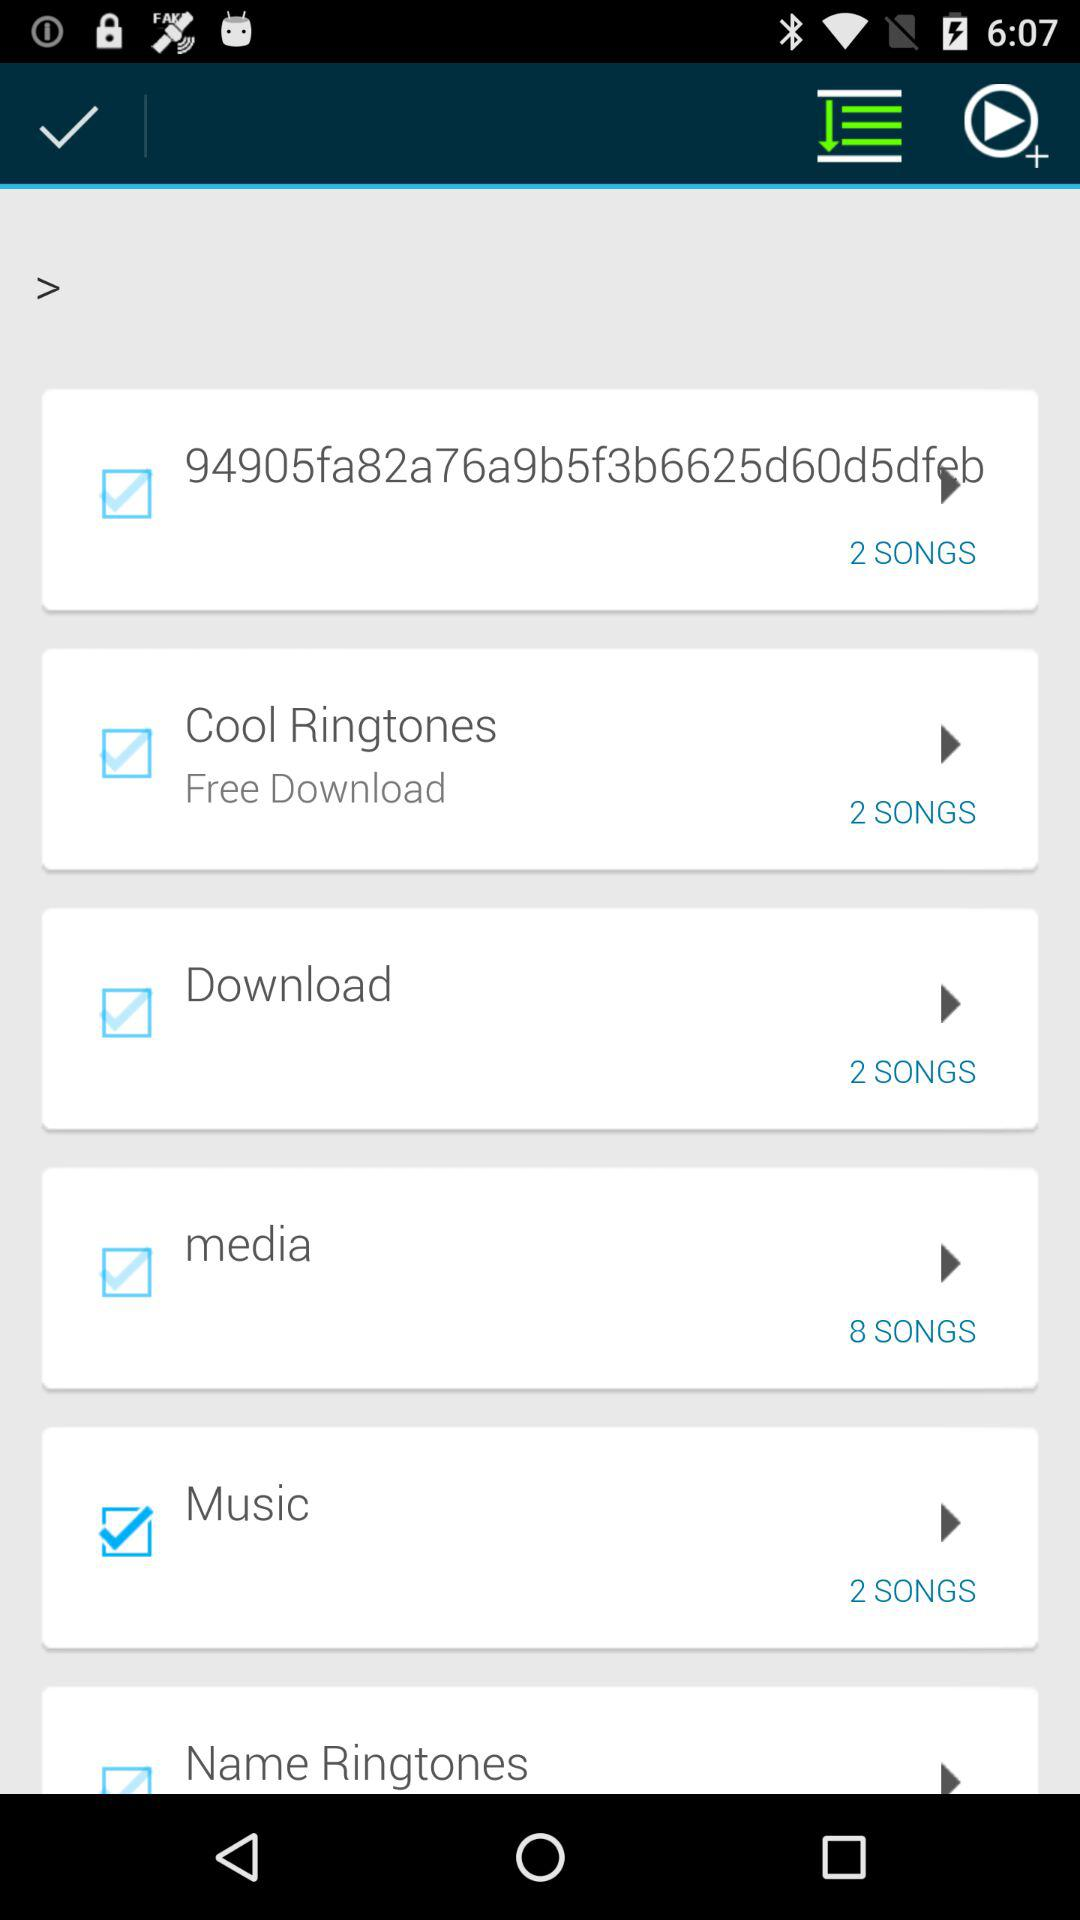How many songs are there in the media section? There are 8 songs. 